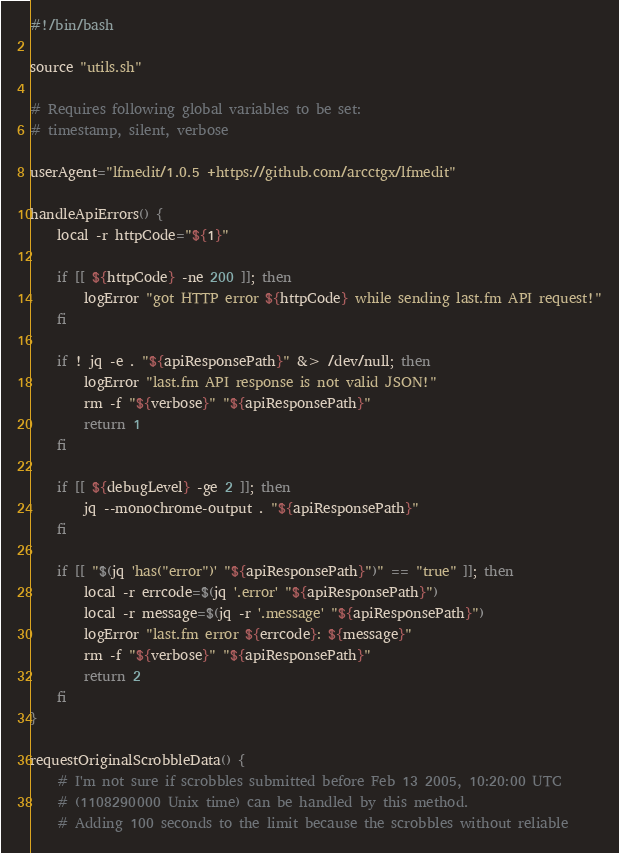Convert code to text. <code><loc_0><loc_0><loc_500><loc_500><_Bash_>#!/bin/bash

source "utils.sh"

# Requires following global variables to be set:
# timestamp, silent, verbose

userAgent="lfmedit/1.0.5 +https://github.com/arcctgx/lfmedit"

handleApiErrors() {
    local -r httpCode="${1}"

    if [[ ${httpCode} -ne 200 ]]; then
        logError "got HTTP error ${httpCode} while sending last.fm API request!"
    fi

    if ! jq -e . "${apiResponsePath}" &> /dev/null; then
        logError "last.fm API response is not valid JSON!"
        rm -f "${verbose}" "${apiResponsePath}"
        return 1
    fi

    if [[ ${debugLevel} -ge 2 ]]; then
        jq --monochrome-output . "${apiResponsePath}"
    fi

    if [[ "$(jq 'has("error")' "${apiResponsePath}")" == "true" ]]; then
        local -r errcode=$(jq '.error' "${apiResponsePath}")
        local -r message=$(jq -r '.message' "${apiResponsePath}")
        logError "last.fm error ${errcode}: ${message}"
        rm -f "${verbose}" "${apiResponsePath}"
        return 2
    fi
}

requestOriginalScrobbleData() {
    # I'm not sure if scrobbles submitted before Feb 13 2005, 10:20:00 UTC
    # (1108290000 Unix time) can be handled by this method.
    # Adding 100 seconds to the limit because the scrobbles without reliable</code> 